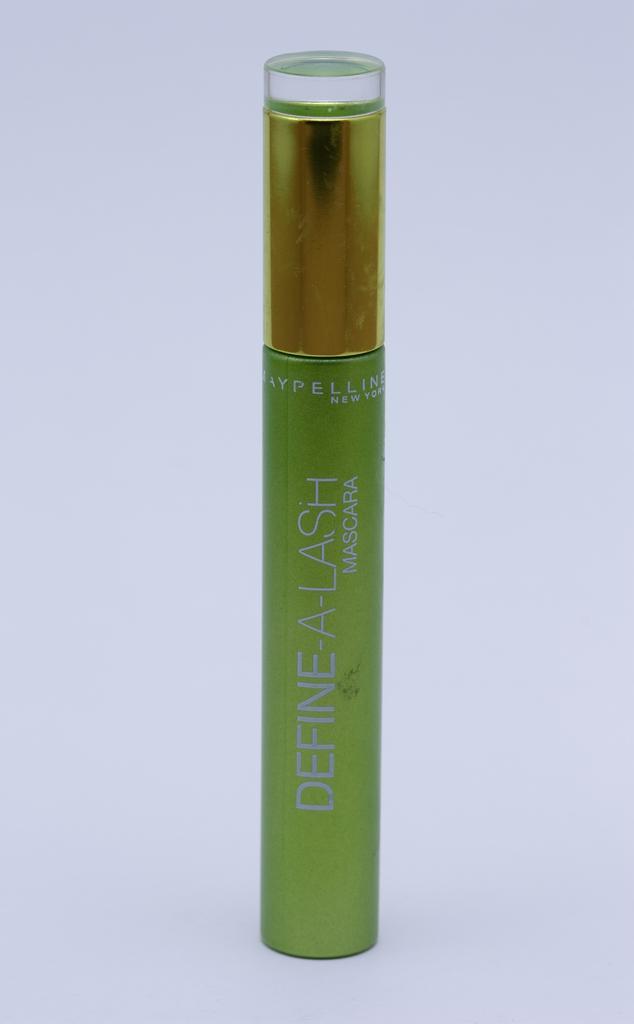Can you describe this image briefly? In this picture I can see cosmetics and a white color background. 